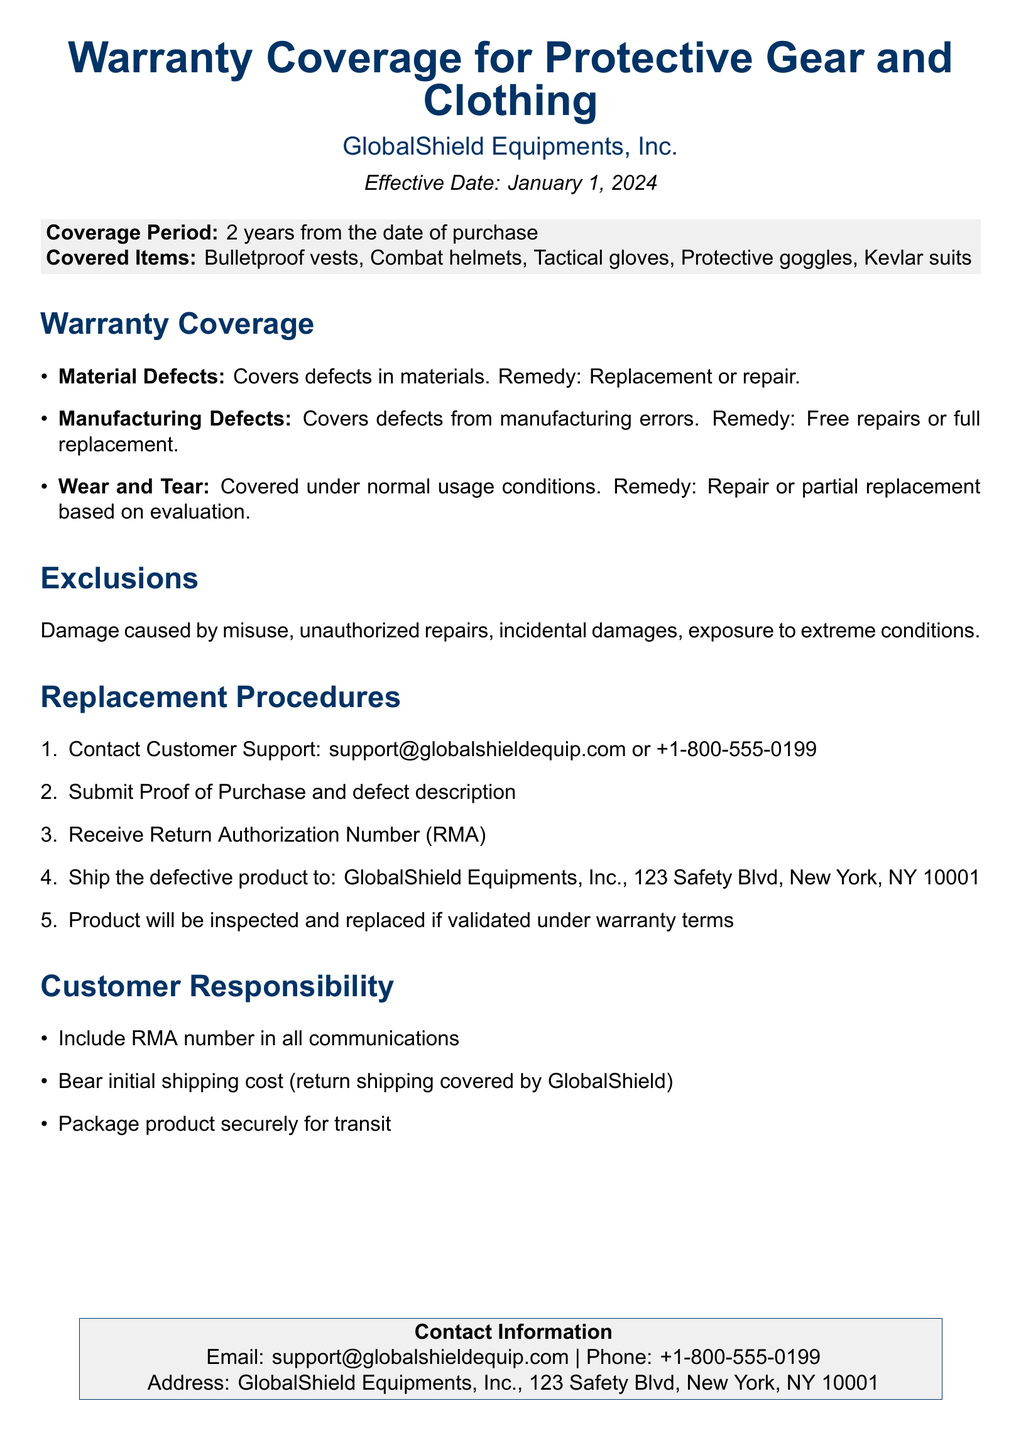What is the warranty coverage period? The coverage period is stated as 2 years from the date of purchase.
Answer: 2 years What items are covered under this warranty? The document lists specific items that are covered.
Answer: Bulletproof vests, Combat helmets, Tactical gloves, Protective goggles, Kevlar suits What is the remedy for material defects? The remedy for material defects is specified in the warranty coverage section.
Answer: Replacement or repair Which damages are excluded from the warranty? The document outlines what damages are not covered by the warranty.
Answer: Misuse, unauthorized repairs, incidental damages, exposure to extreme conditions What must be included in communications with customer support? The document highlights the responsibility of the customer when contacting customer support.
Answer: RMA number How long is the warranty effective from? The effective date of the warranty is noted in the document and determines its duration.
Answer: January 1, 2024 What initial cost must the customer bear when returning a product? The document indicates the customer's responsibility in terms of shipping costs.
Answer: Initial shipping cost What is the first step in the replacement procedure? The document provides a clear sequence of actions for the replacement process.
Answer: Contact Customer Support 